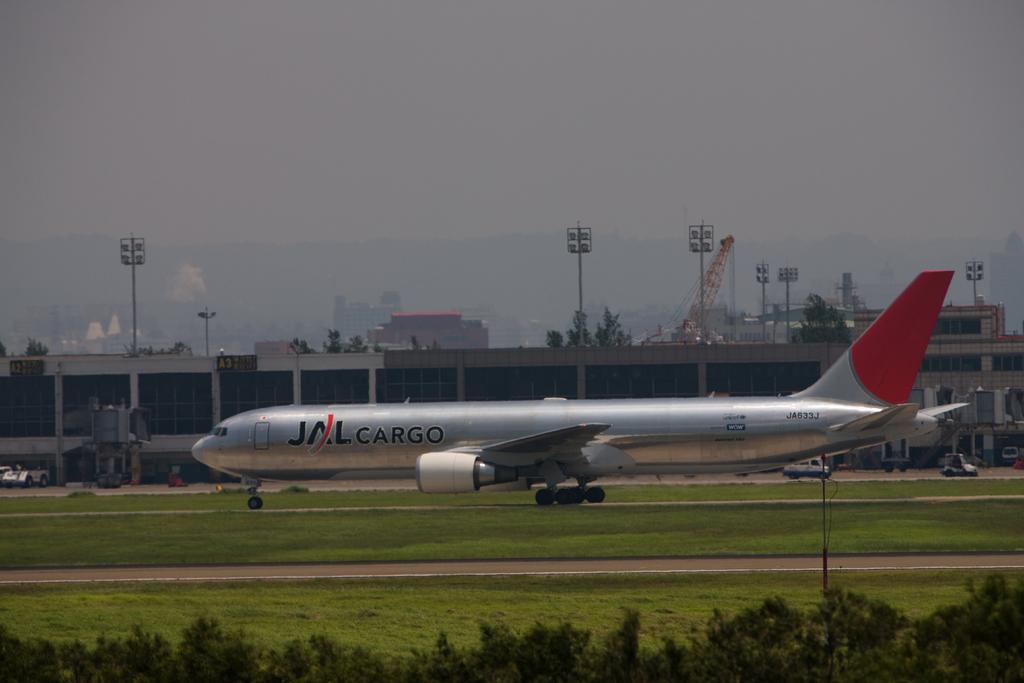Describe this image in one or two sentences. In this image we can see the mountains, one aircraft, one pole, some vehicles, some objects are on the surface, some light poles, some buildings, some trees and green grass on the ground. At the top there is the sky. 